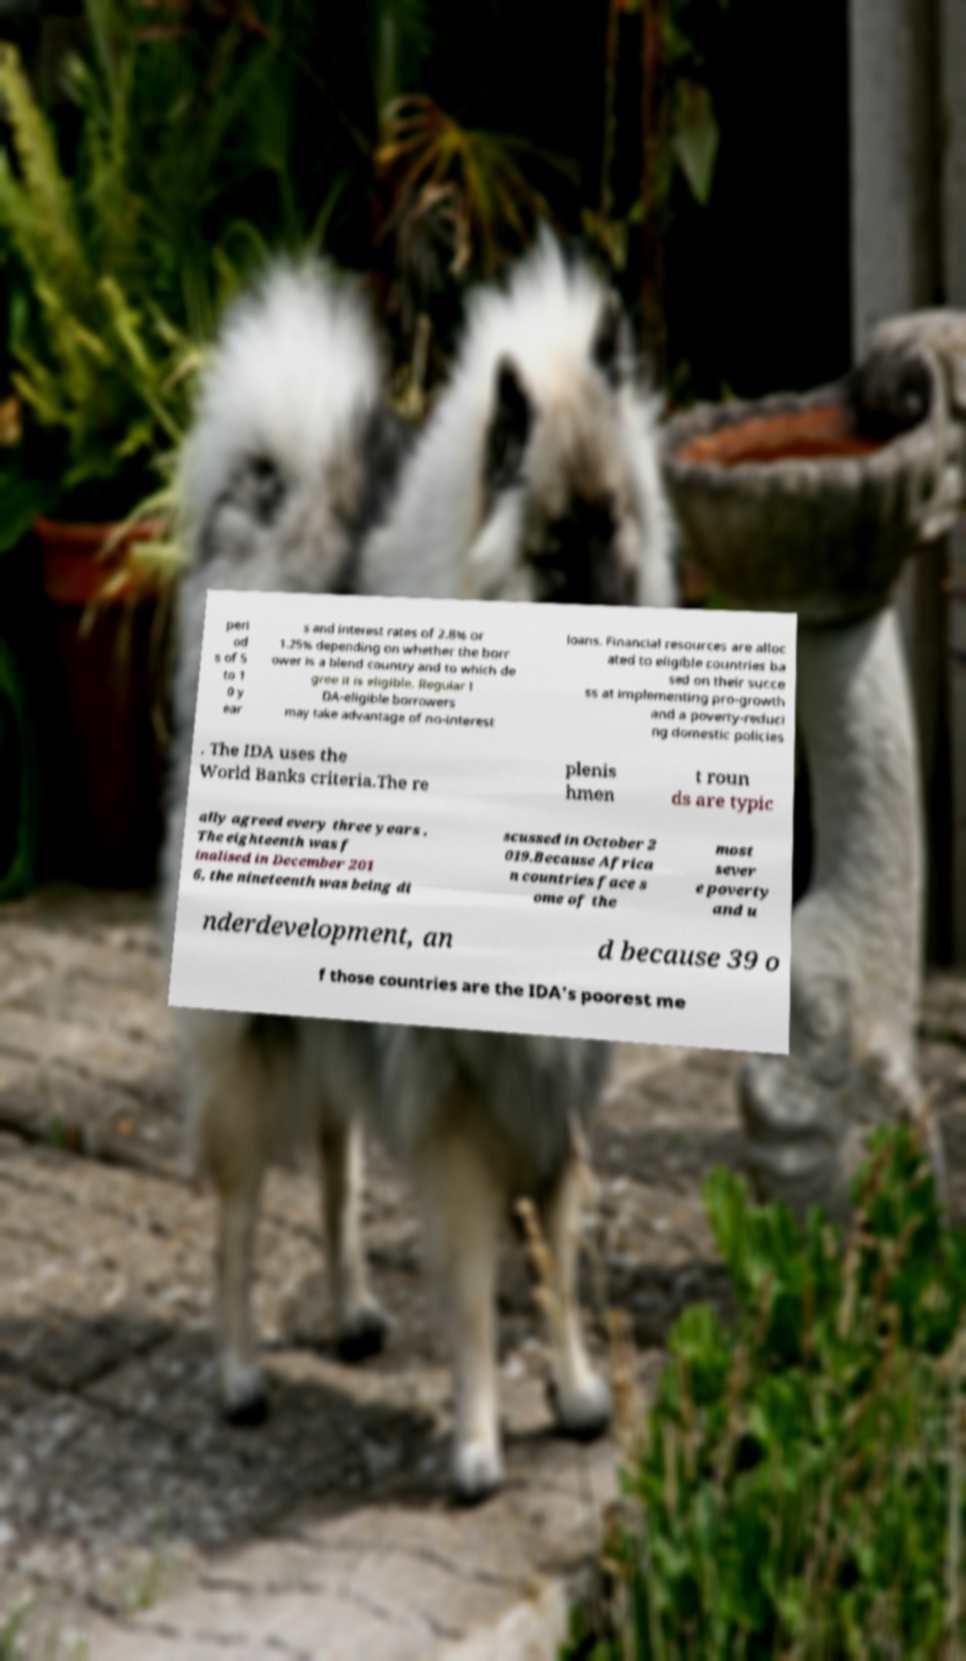There's text embedded in this image that I need extracted. Can you transcribe it verbatim? peri od s of 5 to 1 0 y ear s and interest rates of 2.8% or 1.25% depending on whether the borr ower is a blend country and to which de gree it is eligible. Regular I DA-eligible borrowers may take advantage of no-interest loans. Financial resources are alloc ated to eligible countries ba sed on their succe ss at implementing pro-growth and a poverty-reduci ng domestic policies . The IDA uses the World Banks criteria.The re plenis hmen t roun ds are typic ally agreed every three years . The eighteenth was f inalised in December 201 6, the nineteenth was being di scussed in October 2 019.Because Africa n countries face s ome of the most sever e poverty and u nderdevelopment, an d because 39 o f those countries are the IDA's poorest me 